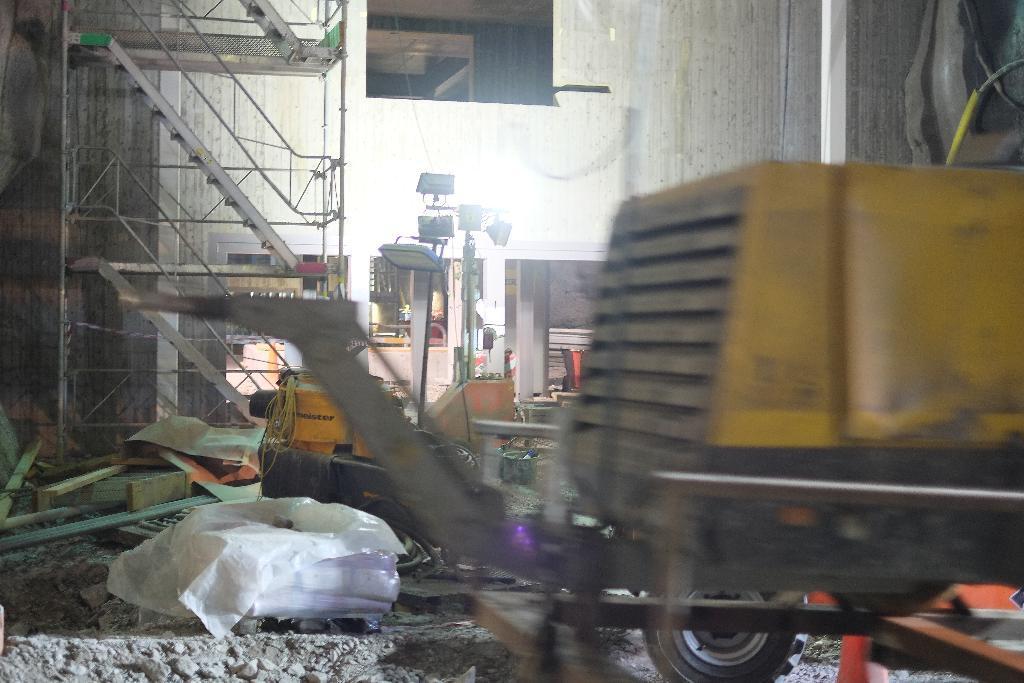In one or two sentences, can you explain what this image depicts? In this picture we can see the view of the warehouse. In the front there is a yellow machine. Behind we can see the focus light stand and a metal staircase steps. In the background there is a white wall and the opening. 